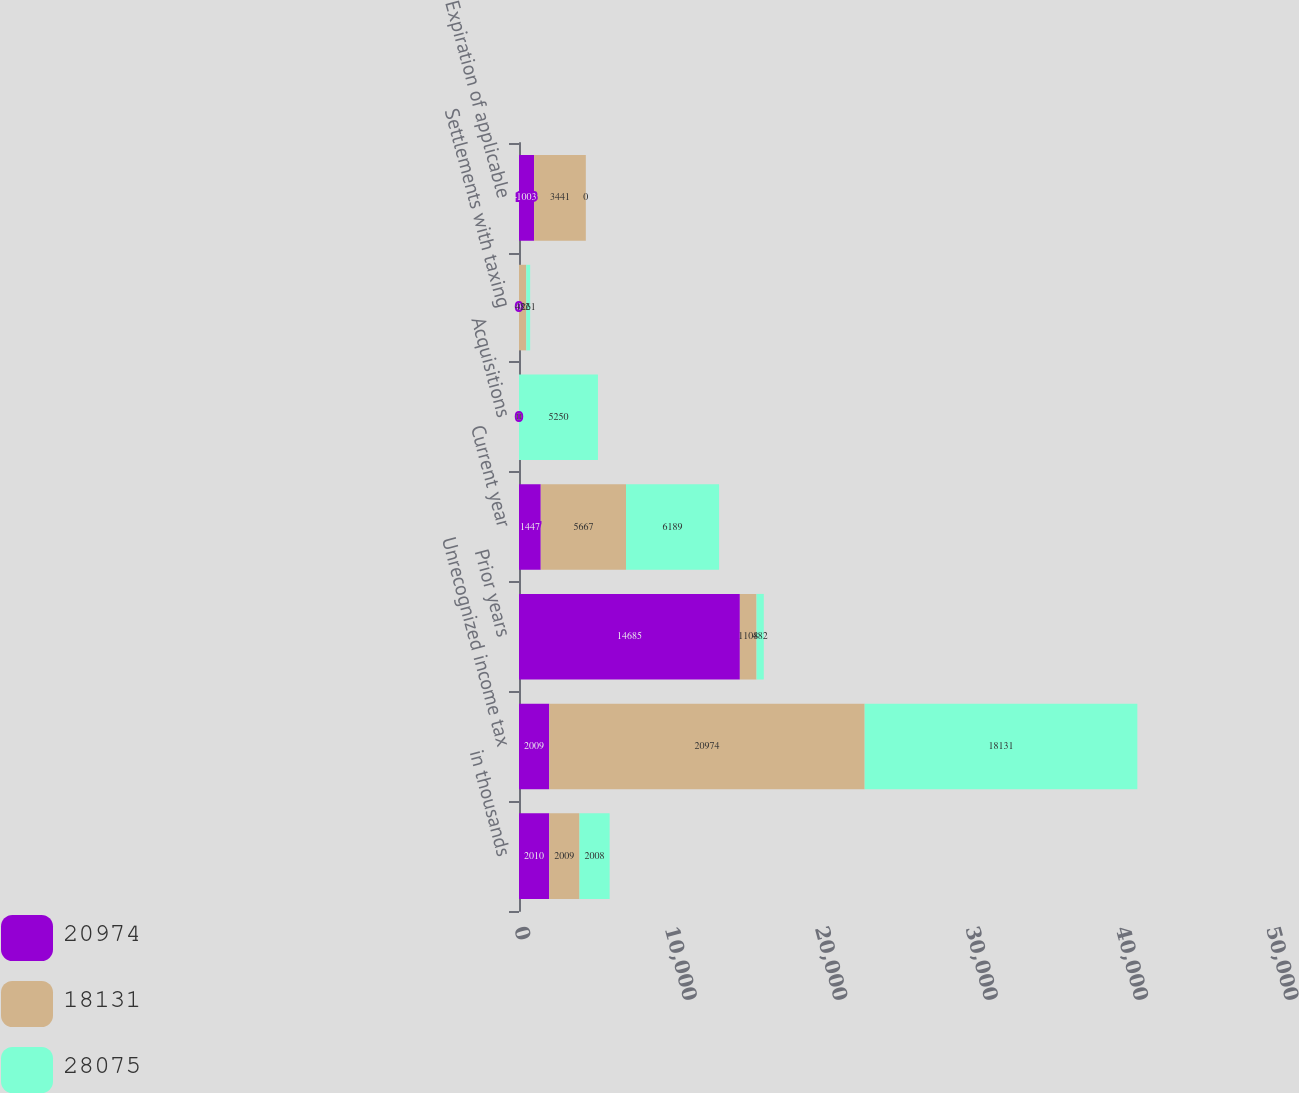Convert chart. <chart><loc_0><loc_0><loc_500><loc_500><stacked_bar_chart><ecel><fcel>in thousands<fcel>Unrecognized income tax<fcel>Prior years<fcel>Current year<fcel>Acquisitions<fcel>Settlements with taxing<fcel>Expiration of applicable<nl><fcel>20974<fcel>2010<fcel>2009<fcel>14685<fcel>1447<fcel>0<fcel>0<fcel>1003<nl><fcel>18131<fcel>2009<fcel>20974<fcel>1108<fcel>5667<fcel>0<fcel>482<fcel>3441<nl><fcel>28075<fcel>2008<fcel>18131<fcel>482<fcel>6189<fcel>5250<fcel>261<fcel>0<nl></chart> 